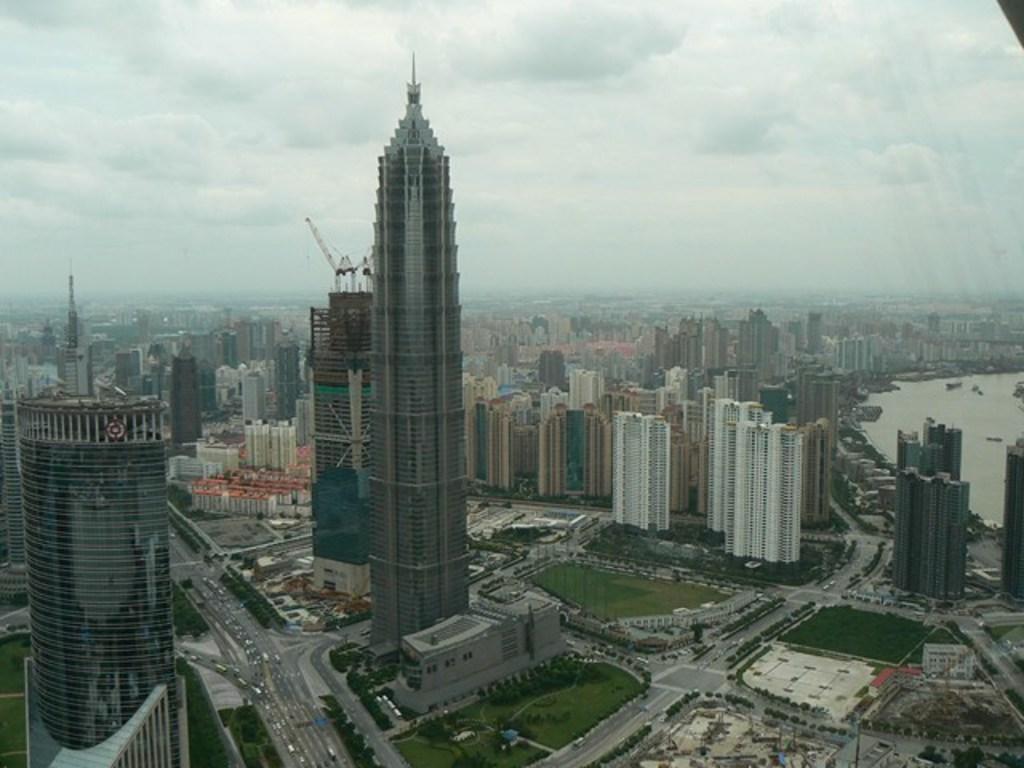In one or two sentences, can you explain what this image depicts? In the foreground of this image, we can see the city, which includes skyscrapers, trees, roads, vehicles and the poles. On the right, there is water. On the top, there is the sky and the cloud. 